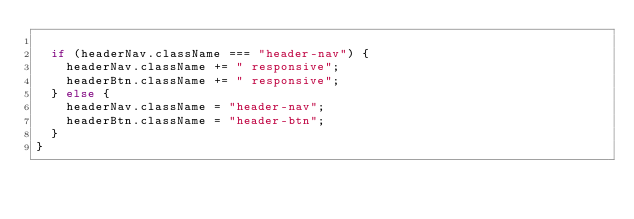<code> <loc_0><loc_0><loc_500><loc_500><_JavaScript_>
  if (headerNav.className === "header-nav") {
    headerNav.className += " responsive";
    headerBtn.className += " responsive";
  } else {
    headerNav.className = "header-nav";
    headerBtn.className = "header-btn";
  }
}
</code> 